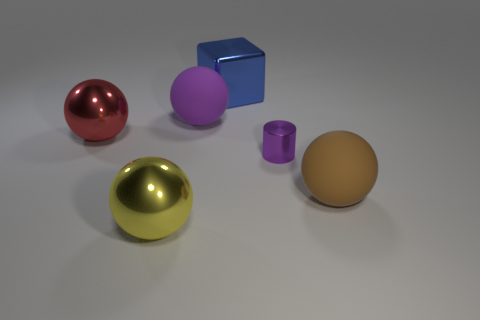Add 2 big red balls. How many objects exist? 8 Subtract all cylinders. How many objects are left? 5 Subtract 0 purple blocks. How many objects are left? 6 Subtract all big red matte cubes. Subtract all small shiny things. How many objects are left? 5 Add 2 large blue metal blocks. How many large blue metal blocks are left? 3 Add 5 tiny purple matte cubes. How many tiny purple matte cubes exist? 5 